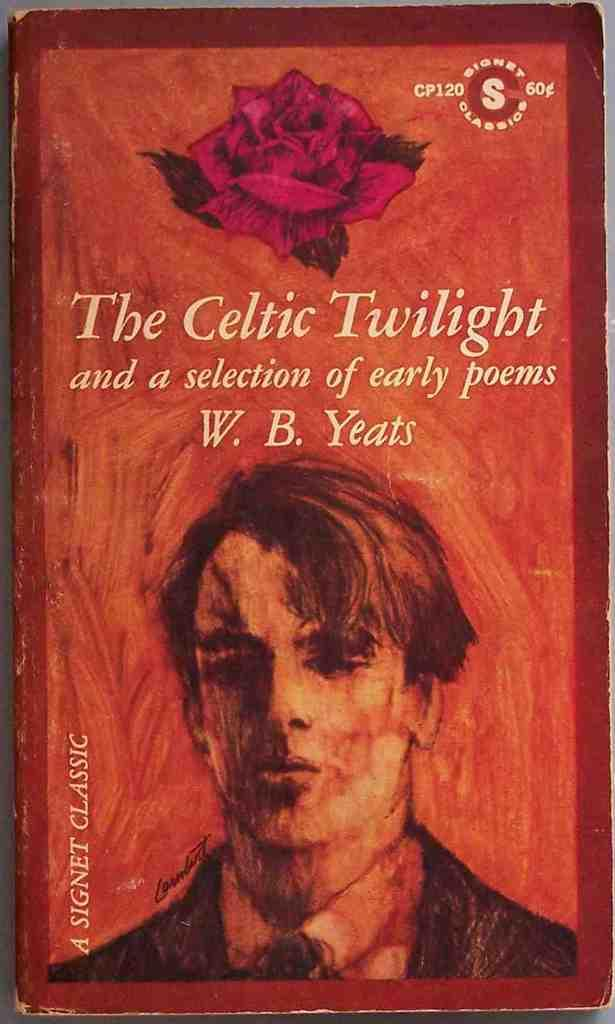What is the main subject of the image? There is a depiction of a person in the image. Are there any words or letters in the image? Yes, there is text in the image. What type of object can be seen at the top of the image? There is a flower at the top of the image. Can you tell me how many dogs are present in the image? There are no dogs present in the image; it features a person and text. What type of vegetable is being used as a prop in the image? There is no vegetable, such as celery or cabbage, present in the image. 